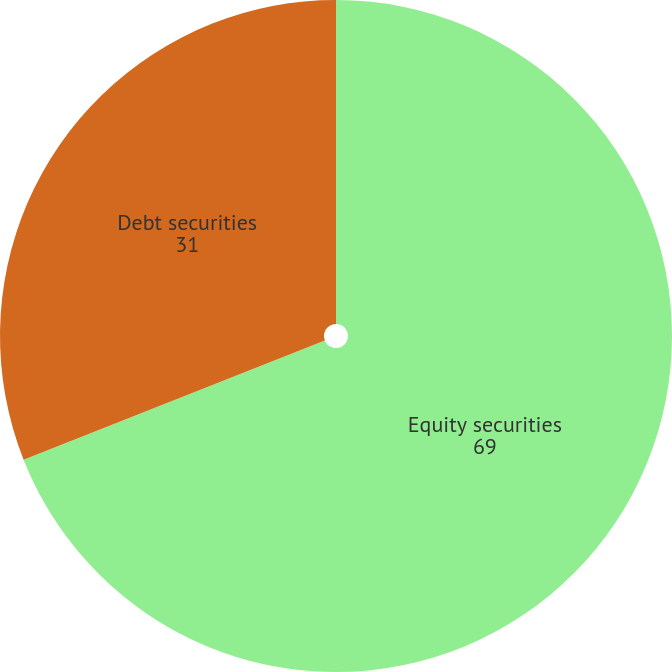Convert chart. <chart><loc_0><loc_0><loc_500><loc_500><pie_chart><fcel>Equity securities<fcel>Debt securities<nl><fcel>69.0%<fcel>31.0%<nl></chart> 